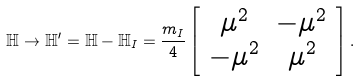<formula> <loc_0><loc_0><loc_500><loc_500>\mathbb { H } \rightarrow \mathbb { H } ^ { \prime } = \mathbb { H } - \mathbb { H } _ { I } = \frac { m _ { I } } { 4 } \left [ \begin{array} { c c } \mu ^ { 2 } & - \mu ^ { 2 } \\ - \mu ^ { 2 } & \mu ^ { 2 } \end{array} \right ] .</formula> 